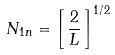Convert formula to latex. <formula><loc_0><loc_0><loc_500><loc_500>N _ { 1 n } = \left [ \, \frac { 2 } { L } \, \right ] ^ { 1 / 2 }</formula> 